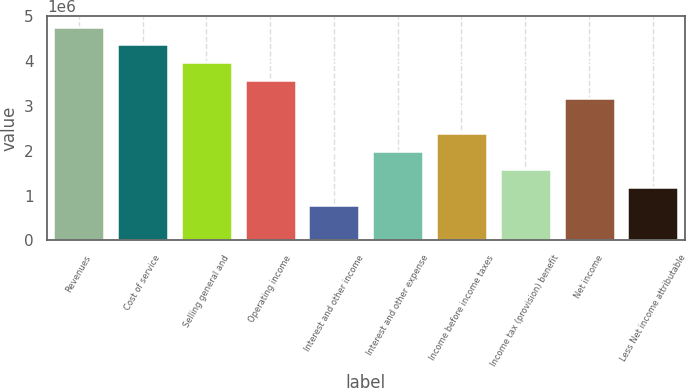Convert chart to OTSL. <chart><loc_0><loc_0><loc_500><loc_500><bar_chart><fcel>Revenues<fcel>Cost of service<fcel>Selling general and<fcel>Operating income<fcel>Interest and other income<fcel>Interest and other expense<fcel>Income before income taxes<fcel>Income tax (provision) benefit<fcel>Net income<fcel>Less Net income attributable<nl><fcel>4.7702e+06<fcel>4.37268e+06<fcel>3.97516e+06<fcel>3.57765e+06<fcel>795035<fcel>1.98758e+06<fcel>2.3851e+06<fcel>1.59007e+06<fcel>3.18013e+06<fcel>1.19255e+06<nl></chart> 